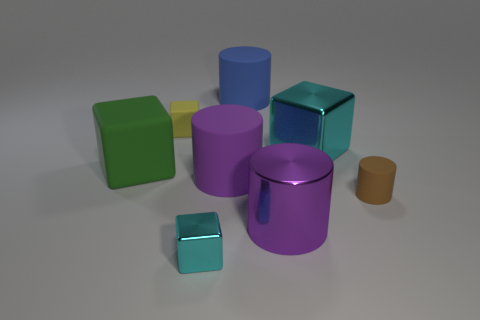How many objects are large cubes to the right of the tiny cyan metal thing or large blue rubber things?
Provide a succinct answer. 2. Are there more tiny brown matte things to the right of the purple metal thing than big cylinders that are on the left side of the small yellow rubber thing?
Give a very brief answer. Yes. How many rubber objects are large blue cylinders or tiny green spheres?
Your answer should be compact. 1. What material is the other block that is the same color as the small metallic block?
Ensure brevity in your answer.  Metal. Is the number of tiny cyan cubes that are behind the small yellow rubber cube less than the number of purple things on the right side of the small cyan object?
Your answer should be compact. Yes. What number of objects are green blocks or cylinders in front of the large metal cube?
Provide a short and direct response. 4. There is a cyan block that is the same size as the brown cylinder; what is it made of?
Offer a terse response. Metal. Do the brown cylinder and the yellow thing have the same material?
Ensure brevity in your answer.  Yes. What color is the thing that is in front of the brown object and left of the big metal cylinder?
Offer a very short reply. Cyan. There is a tiny rubber thing that is right of the large blue matte object; is it the same color as the tiny rubber block?
Your answer should be compact. No. 